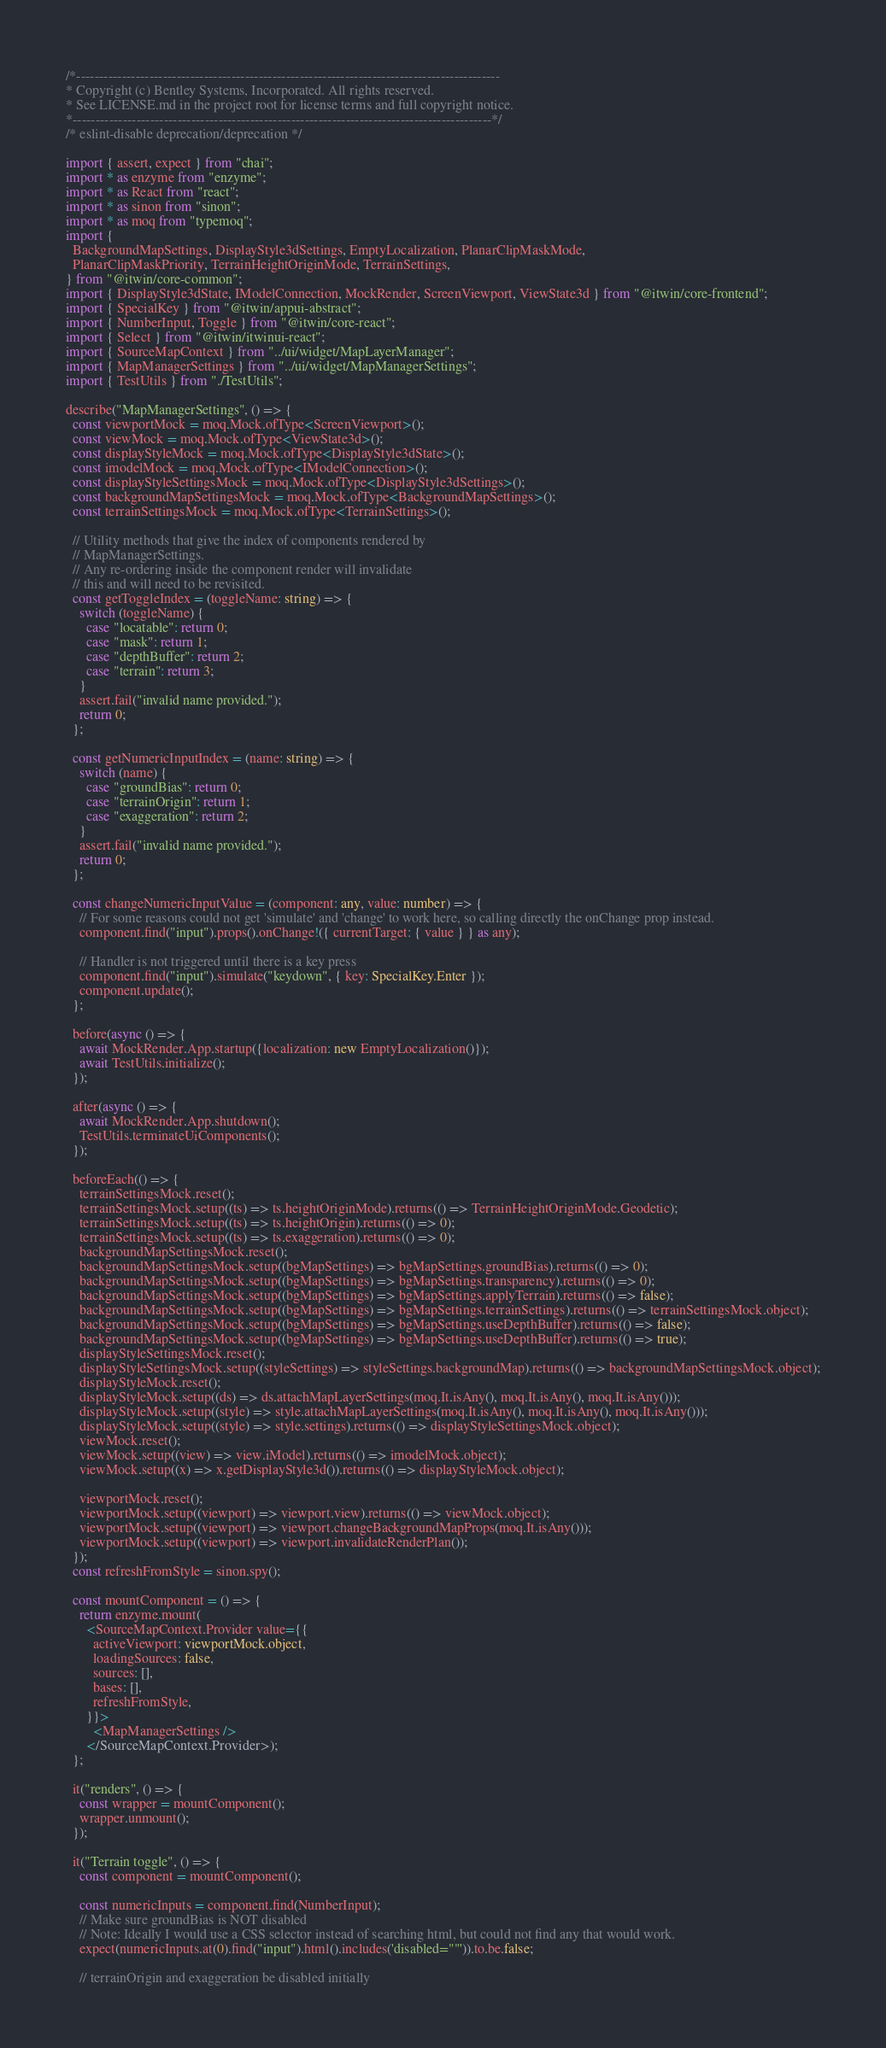Convert code to text. <code><loc_0><loc_0><loc_500><loc_500><_TypeScript_>/*---------------------------------------------------------------------------------------------
* Copyright (c) Bentley Systems, Incorporated. All rights reserved.
* See LICENSE.md in the project root for license terms and full copyright notice.
*--------------------------------------------------------------------------------------------*/
/* eslint-disable deprecation/deprecation */

import { assert, expect } from "chai";
import * as enzyme from "enzyme";
import * as React from "react";
import * as sinon from "sinon";
import * as moq from "typemoq";
import {
  BackgroundMapSettings, DisplayStyle3dSettings, EmptyLocalization, PlanarClipMaskMode,
  PlanarClipMaskPriority, TerrainHeightOriginMode, TerrainSettings,
} from "@itwin/core-common";
import { DisplayStyle3dState, IModelConnection, MockRender, ScreenViewport, ViewState3d } from "@itwin/core-frontend";
import { SpecialKey } from "@itwin/appui-abstract";
import { NumberInput, Toggle } from "@itwin/core-react";
import { Select } from "@itwin/itwinui-react";
import { SourceMapContext } from "../ui/widget/MapLayerManager";
import { MapManagerSettings } from "../ui/widget/MapManagerSettings";
import { TestUtils } from "./TestUtils";

describe("MapManagerSettings", () => {
  const viewportMock = moq.Mock.ofType<ScreenViewport>();
  const viewMock = moq.Mock.ofType<ViewState3d>();
  const displayStyleMock = moq.Mock.ofType<DisplayStyle3dState>();
  const imodelMock = moq.Mock.ofType<IModelConnection>();
  const displayStyleSettingsMock = moq.Mock.ofType<DisplayStyle3dSettings>();
  const backgroundMapSettingsMock = moq.Mock.ofType<BackgroundMapSettings>();
  const terrainSettingsMock = moq.Mock.ofType<TerrainSettings>();

  // Utility methods that give the index of components rendered by
  // MapManagerSettings.
  // Any re-ordering inside the component render will invalidate
  // this and will need to be revisited.
  const getToggleIndex = (toggleName: string) => {
    switch (toggleName) {
      case "locatable": return 0;
      case "mask": return 1;
      case "depthBuffer": return 2;
      case "terrain": return 3;
    }
    assert.fail("invalid name provided.");
    return 0;
  };

  const getNumericInputIndex = (name: string) => {
    switch (name) {
      case "groundBias": return 0;
      case "terrainOrigin": return 1;
      case "exaggeration": return 2;
    }
    assert.fail("invalid name provided.");
    return 0;
  };

  const changeNumericInputValue = (component: any, value: number) => {
    // For some reasons could not get 'simulate' and 'change' to work here, so calling directly the onChange prop instead.
    component.find("input").props().onChange!({ currentTarget: { value } } as any);

    // Handler is not triggered until there is a key press
    component.find("input").simulate("keydown", { key: SpecialKey.Enter });
    component.update();
  };

  before(async () => {
    await MockRender.App.startup({localization: new EmptyLocalization()});
    await TestUtils.initialize();
  });

  after(async () => {
    await MockRender.App.shutdown();
    TestUtils.terminateUiComponents();
  });

  beforeEach(() => {
    terrainSettingsMock.reset();
    terrainSettingsMock.setup((ts) => ts.heightOriginMode).returns(() => TerrainHeightOriginMode.Geodetic);
    terrainSettingsMock.setup((ts) => ts.heightOrigin).returns(() => 0);
    terrainSettingsMock.setup((ts) => ts.exaggeration).returns(() => 0);
    backgroundMapSettingsMock.reset();
    backgroundMapSettingsMock.setup((bgMapSettings) => bgMapSettings.groundBias).returns(() => 0);
    backgroundMapSettingsMock.setup((bgMapSettings) => bgMapSettings.transparency).returns(() => 0);
    backgroundMapSettingsMock.setup((bgMapSettings) => bgMapSettings.applyTerrain).returns(() => false);
    backgroundMapSettingsMock.setup((bgMapSettings) => bgMapSettings.terrainSettings).returns(() => terrainSettingsMock.object);
    backgroundMapSettingsMock.setup((bgMapSettings) => bgMapSettings.useDepthBuffer).returns(() => false);
    backgroundMapSettingsMock.setup((bgMapSettings) => bgMapSettings.useDepthBuffer).returns(() => true);
    displayStyleSettingsMock.reset();
    displayStyleSettingsMock.setup((styleSettings) => styleSettings.backgroundMap).returns(() => backgroundMapSettingsMock.object);
    displayStyleMock.reset();
    displayStyleMock.setup((ds) => ds.attachMapLayerSettings(moq.It.isAny(), moq.It.isAny(), moq.It.isAny()));
    displayStyleMock.setup((style) => style.attachMapLayerSettings(moq.It.isAny(), moq.It.isAny(), moq.It.isAny()));
    displayStyleMock.setup((style) => style.settings).returns(() => displayStyleSettingsMock.object);
    viewMock.reset();
    viewMock.setup((view) => view.iModel).returns(() => imodelMock.object);
    viewMock.setup((x) => x.getDisplayStyle3d()).returns(() => displayStyleMock.object);

    viewportMock.reset();
    viewportMock.setup((viewport) => viewport.view).returns(() => viewMock.object);
    viewportMock.setup((viewport) => viewport.changeBackgroundMapProps(moq.It.isAny()));
    viewportMock.setup((viewport) => viewport.invalidateRenderPlan());
  });
  const refreshFromStyle = sinon.spy();

  const mountComponent = () => {
    return enzyme.mount(
      <SourceMapContext.Provider value={{
        activeViewport: viewportMock.object,
        loadingSources: false,
        sources: [],
        bases: [],
        refreshFromStyle,
      }}>
        <MapManagerSettings />
      </SourceMapContext.Provider>);
  };

  it("renders", () => {
    const wrapper = mountComponent();
    wrapper.unmount();
  });

  it("Terrain toggle", () => {
    const component = mountComponent();

    const numericInputs = component.find(NumberInput);
    // Make sure groundBias is NOT disabled
    // Note: Ideally I would use a CSS selector instead of searching html, but could not find any that would work.
    expect(numericInputs.at(0).find("input").html().includes('disabled=""')).to.be.false;

    // terrainOrigin and exaggeration be disabled initially</code> 